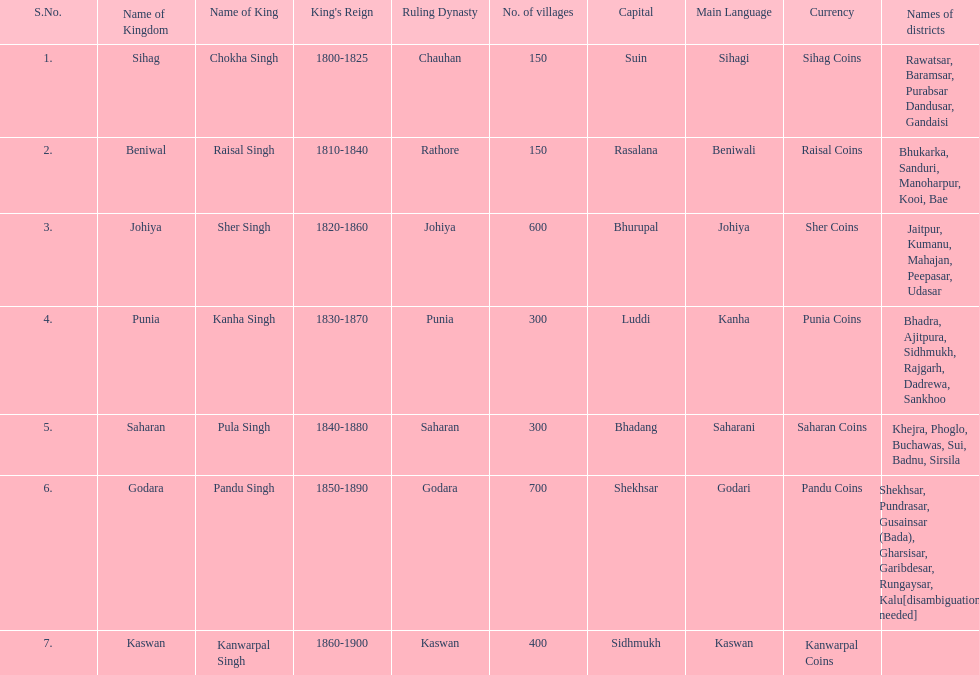What was the total number of districts within the state of godara? 7. 